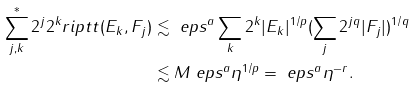<formula> <loc_0><loc_0><loc_500><loc_500>\sum _ { j , k } ^ { * } 2 ^ { j } 2 ^ { k } r i p t t ( E _ { k } , F _ { j } ) & \lesssim \ e p s ^ { a } \sum _ { k } 2 ^ { k } | E _ { k } | ^ { 1 / p } ( \sum _ { j } 2 ^ { j q } | F _ { j } | ) ^ { 1 / q } \\ & \lesssim M \ e p s ^ { a } \eta ^ { 1 / p } = \ e p s ^ { a } \eta ^ { - r } .</formula> 